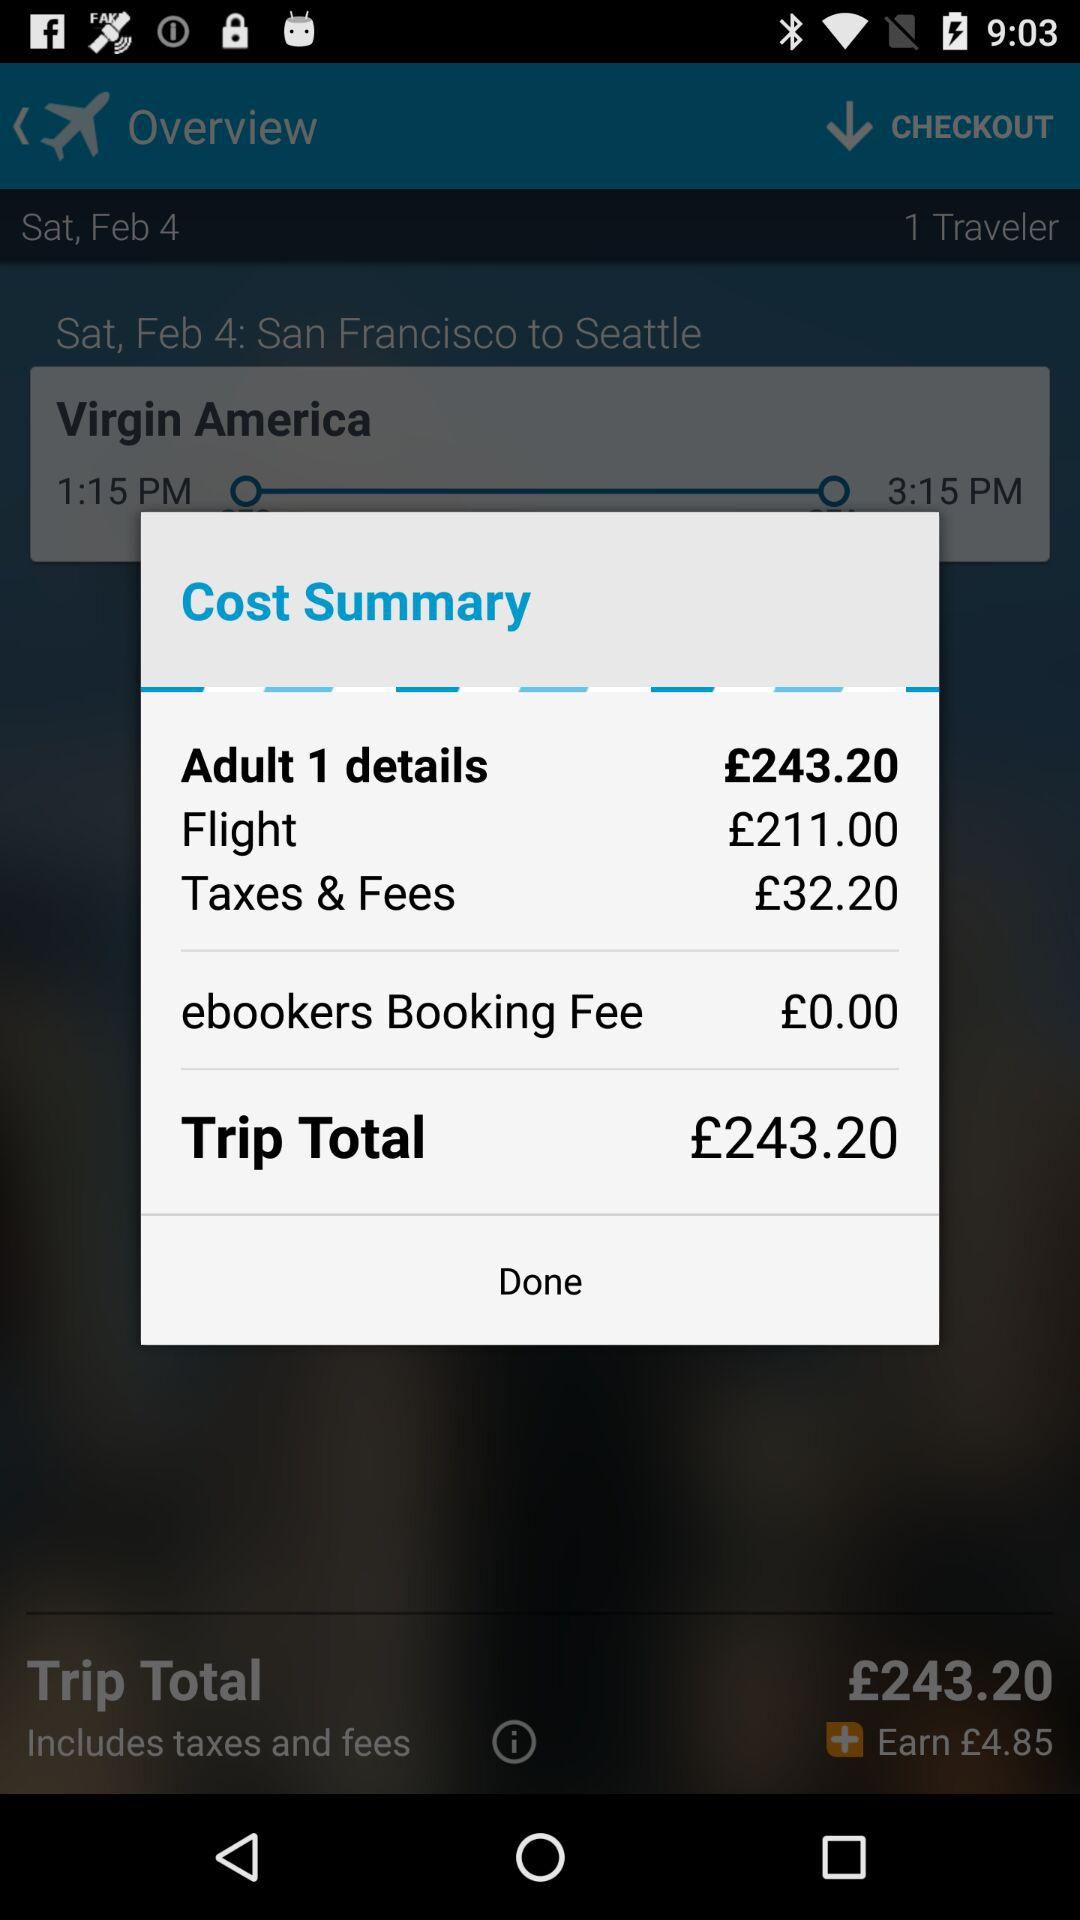How much is the total trip fare? The total trip fare is £243.20. 